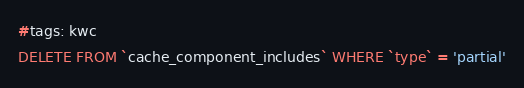Convert code to text. <code><loc_0><loc_0><loc_500><loc_500><_SQL_>#tags: kwc
DELETE FROM `cache_component_includes` WHERE `type` = 'partial'
</code> 